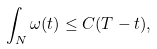Convert formula to latex. <formula><loc_0><loc_0><loc_500><loc_500>\int _ { N } \omega ( t ) \leq C ( T - t ) ,</formula> 